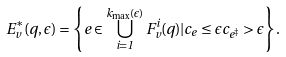Convert formula to latex. <formula><loc_0><loc_0><loc_500><loc_500>E ^ { * } _ { v } ( q , \epsilon ) = \left \{ e \in \bigcup _ { i = 1 } ^ { k _ { \max } ( \epsilon ) } F ^ { i } _ { v } ( q ) | c _ { e } \leq \epsilon c _ { e ^ { \ddagger } } > \epsilon \right \} .</formula> 